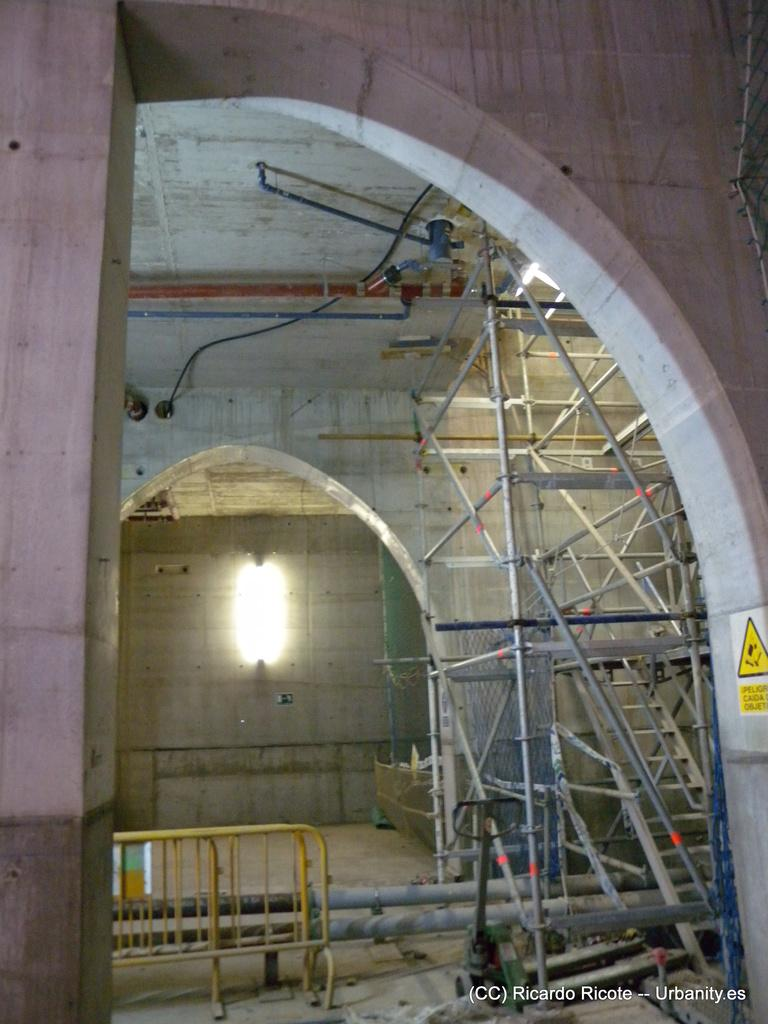What type of structure is visible in the image? There are iron grills and walls visible in the image. Can you describe the lighting in the image? There is an electric light in the image. How many sheep can be seen grazing near the walls in the image? There are no sheep present in the image; it features iron grills and walls with an electric light. What type of lumber is used to construct the walls in the image? The walls in the image are not made of lumber; they are made of a different material, likely brick or concrete. 